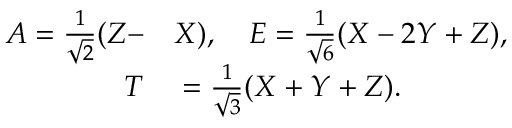Convert formula to latex. <formula><loc_0><loc_0><loc_500><loc_500>\begin{array} { r l } { A = \frac { 1 } { \sqrt { 2 } } ( Z - } & X ) , \quad E = \frac { 1 } { \sqrt { 6 } } ( X - 2 Y + Z ) , } \\ { T } & = \frac { 1 } { \sqrt { 3 } } ( X + Y + Z ) . } \end{array}</formula> 